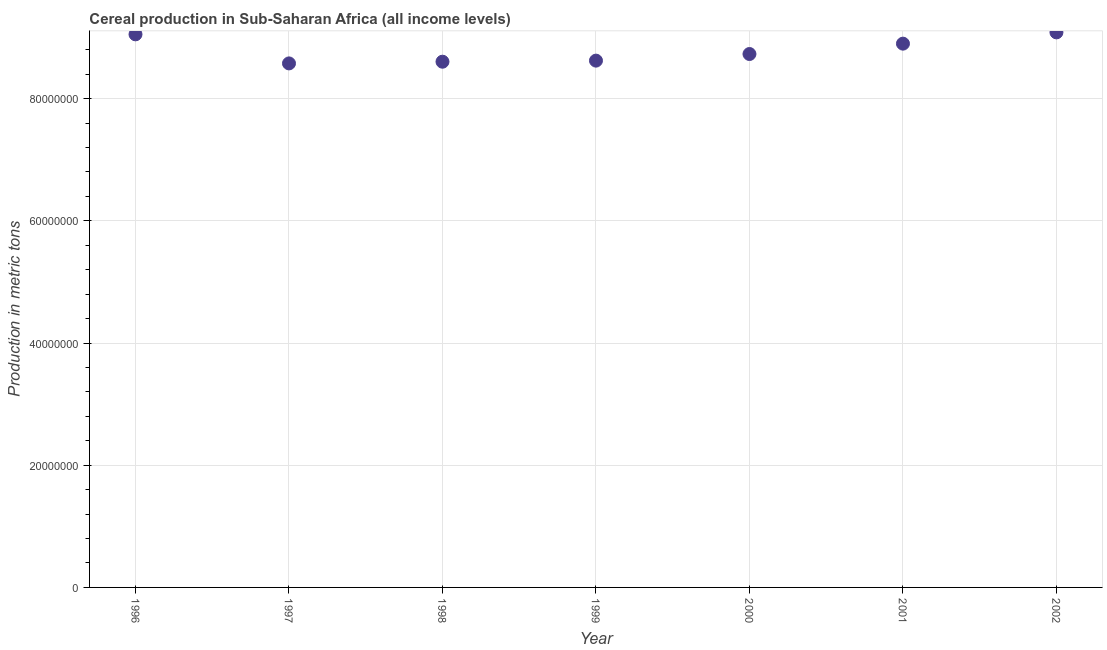What is the cereal production in 1998?
Provide a short and direct response. 8.60e+07. Across all years, what is the maximum cereal production?
Offer a very short reply. 9.08e+07. Across all years, what is the minimum cereal production?
Ensure brevity in your answer.  8.58e+07. In which year was the cereal production minimum?
Ensure brevity in your answer.  1997. What is the sum of the cereal production?
Offer a terse response. 6.16e+08. What is the difference between the cereal production in 1999 and 2000?
Your answer should be very brief. -1.08e+06. What is the average cereal production per year?
Offer a terse response. 8.80e+07. What is the median cereal production?
Provide a short and direct response. 8.73e+07. Do a majority of the years between 1998 and 2002 (inclusive) have cereal production greater than 8000000 metric tons?
Provide a short and direct response. Yes. What is the ratio of the cereal production in 1996 to that in 1997?
Your answer should be compact. 1.06. What is the difference between the highest and the second highest cereal production?
Provide a succinct answer. 3.21e+05. Is the sum of the cereal production in 1998 and 2002 greater than the maximum cereal production across all years?
Offer a terse response. Yes. What is the difference between the highest and the lowest cereal production?
Your answer should be very brief. 5.08e+06. How many years are there in the graph?
Give a very brief answer. 7. What is the difference between two consecutive major ticks on the Y-axis?
Keep it short and to the point. 2.00e+07. Are the values on the major ticks of Y-axis written in scientific E-notation?
Your answer should be very brief. No. Does the graph contain grids?
Provide a succinct answer. Yes. What is the title of the graph?
Provide a short and direct response. Cereal production in Sub-Saharan Africa (all income levels). What is the label or title of the Y-axis?
Make the answer very short. Production in metric tons. What is the Production in metric tons in 1996?
Ensure brevity in your answer.  9.05e+07. What is the Production in metric tons in 1997?
Keep it short and to the point. 8.58e+07. What is the Production in metric tons in 1998?
Offer a terse response. 8.60e+07. What is the Production in metric tons in 1999?
Provide a short and direct response. 8.62e+07. What is the Production in metric tons in 2000?
Your answer should be very brief. 8.73e+07. What is the Production in metric tons in 2001?
Your answer should be compact. 8.90e+07. What is the Production in metric tons in 2002?
Your response must be concise. 9.08e+07. What is the difference between the Production in metric tons in 1996 and 1997?
Your answer should be very brief. 4.76e+06. What is the difference between the Production in metric tons in 1996 and 1998?
Make the answer very short. 4.48e+06. What is the difference between the Production in metric tons in 1996 and 1999?
Give a very brief answer. 4.30e+06. What is the difference between the Production in metric tons in 1996 and 2000?
Keep it short and to the point. 3.22e+06. What is the difference between the Production in metric tons in 1996 and 2001?
Your answer should be compact. 1.52e+06. What is the difference between the Production in metric tons in 1996 and 2002?
Your answer should be very brief. -3.21e+05. What is the difference between the Production in metric tons in 1997 and 1998?
Offer a terse response. -2.78e+05. What is the difference between the Production in metric tons in 1997 and 1999?
Keep it short and to the point. -4.54e+05. What is the difference between the Production in metric tons in 1997 and 2000?
Give a very brief answer. -1.54e+06. What is the difference between the Production in metric tons in 1997 and 2001?
Ensure brevity in your answer.  -3.23e+06. What is the difference between the Production in metric tons in 1997 and 2002?
Your answer should be very brief. -5.08e+06. What is the difference between the Production in metric tons in 1998 and 1999?
Provide a short and direct response. -1.76e+05. What is the difference between the Production in metric tons in 1998 and 2000?
Make the answer very short. -1.26e+06. What is the difference between the Production in metric tons in 1998 and 2001?
Offer a very short reply. -2.96e+06. What is the difference between the Production in metric tons in 1998 and 2002?
Your answer should be compact. -4.80e+06. What is the difference between the Production in metric tons in 1999 and 2000?
Offer a very short reply. -1.08e+06. What is the difference between the Production in metric tons in 1999 and 2001?
Provide a succinct answer. -2.78e+06. What is the difference between the Production in metric tons in 1999 and 2002?
Your response must be concise. -4.62e+06. What is the difference between the Production in metric tons in 2000 and 2001?
Your response must be concise. -1.70e+06. What is the difference between the Production in metric tons in 2000 and 2002?
Give a very brief answer. -3.54e+06. What is the difference between the Production in metric tons in 2001 and 2002?
Keep it short and to the point. -1.85e+06. What is the ratio of the Production in metric tons in 1996 to that in 1997?
Give a very brief answer. 1.05. What is the ratio of the Production in metric tons in 1996 to that in 1998?
Your answer should be very brief. 1.05. What is the ratio of the Production in metric tons in 1996 to that in 1999?
Give a very brief answer. 1.05. What is the ratio of the Production in metric tons in 1996 to that in 2001?
Make the answer very short. 1.02. What is the ratio of the Production in metric tons in 1996 to that in 2002?
Ensure brevity in your answer.  1. What is the ratio of the Production in metric tons in 1997 to that in 1999?
Ensure brevity in your answer.  0.99. What is the ratio of the Production in metric tons in 1997 to that in 2000?
Give a very brief answer. 0.98. What is the ratio of the Production in metric tons in 1997 to that in 2002?
Give a very brief answer. 0.94. What is the ratio of the Production in metric tons in 1998 to that in 2002?
Ensure brevity in your answer.  0.95. What is the ratio of the Production in metric tons in 1999 to that in 2000?
Your answer should be very brief. 0.99. What is the ratio of the Production in metric tons in 1999 to that in 2002?
Offer a terse response. 0.95. What is the ratio of the Production in metric tons in 2000 to that in 2001?
Your response must be concise. 0.98. What is the ratio of the Production in metric tons in 2000 to that in 2002?
Your response must be concise. 0.96. 